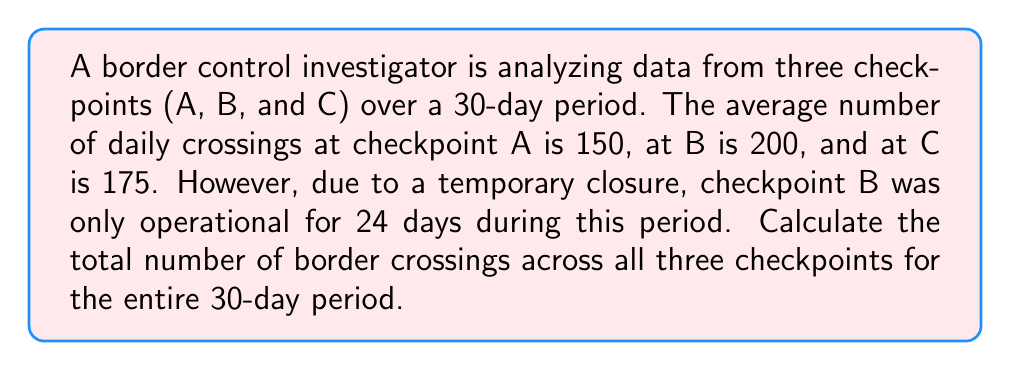Could you help me with this problem? Let's break this down step-by-step:

1) First, calculate the total crossings for checkpoint A:
   $$ A_{total} = 150 \text{ crossings/day} \times 30 \text{ days} = 4,500 \text{ crossings} $$

2) For checkpoint B, which was only operational for 24 days:
   $$ B_{total} = 200 \text{ crossings/day} \times 24 \text{ days} = 4,800 \text{ crossings} $$

3) For checkpoint C:
   $$ C_{total} = 175 \text{ crossings/day} \times 30 \text{ days} = 5,250 \text{ crossings} $$

4) To get the total number of crossings, sum the results from all checkpoints:
   $$ \text{Total crossings} = A_{total} + B_{total} + C_{total} $$
   $$ \text{Total crossings} = 4,500 + 4,800 + 5,250 = 14,550 \text{ crossings} $$

Therefore, the total number of border crossings across all three checkpoints for the entire 30-day period is 14,550.
Answer: 14,550 crossings 